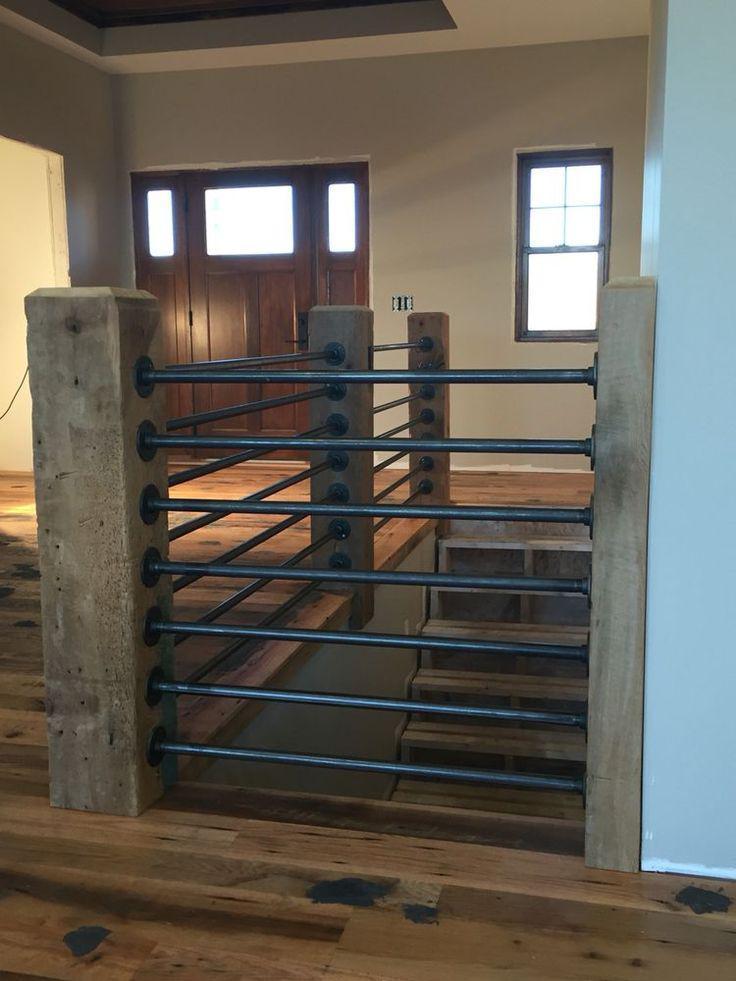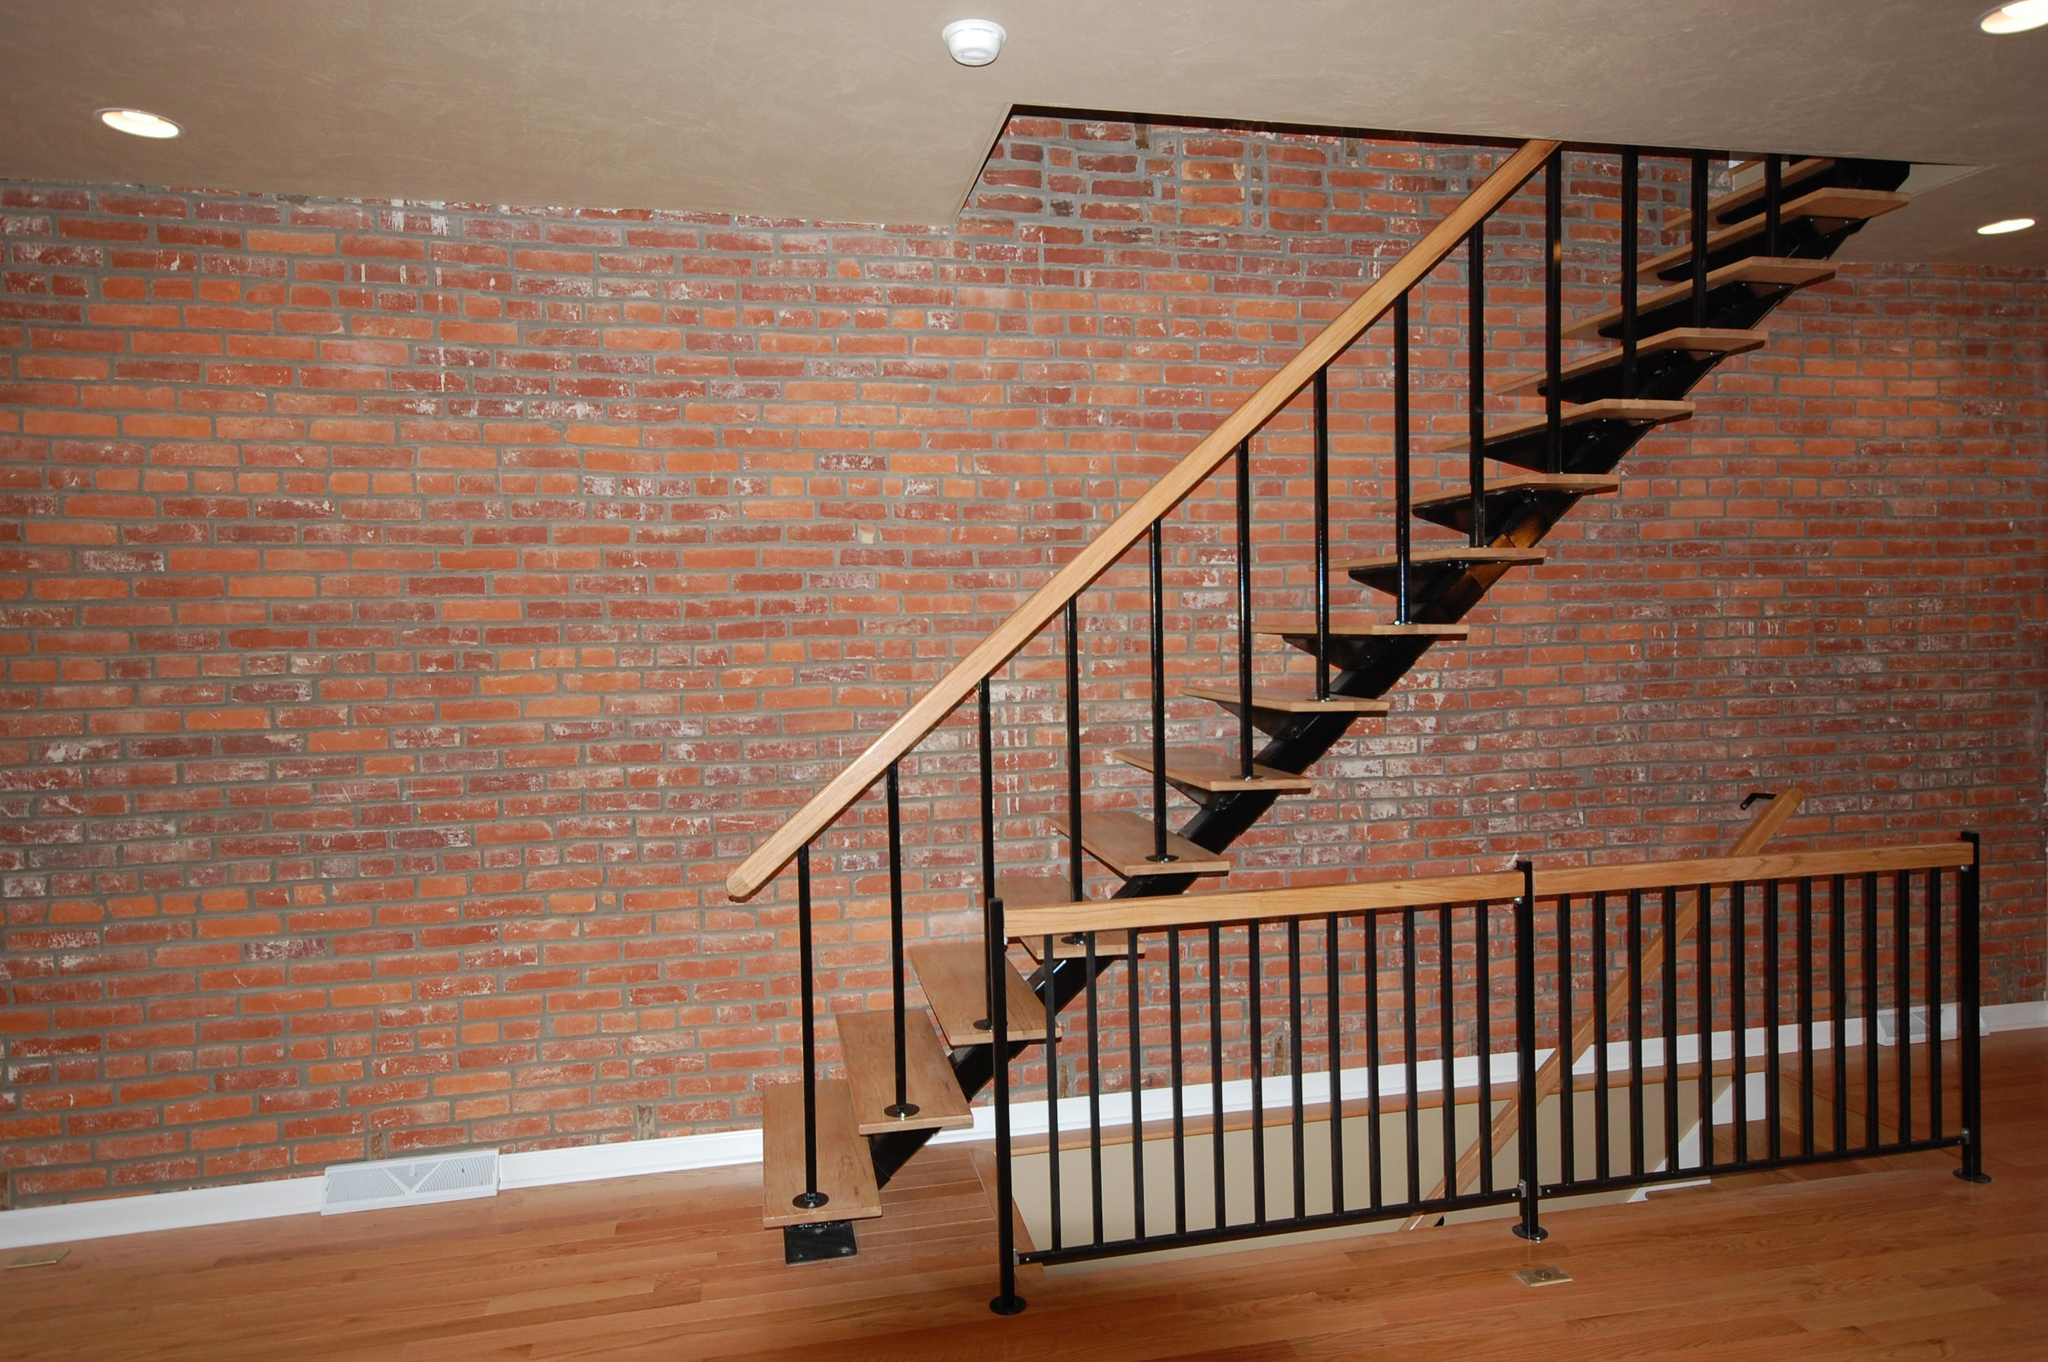The first image is the image on the left, the second image is the image on the right. Considering the images on both sides, is "The right image contains a staircase with a black handrail." valid? Answer yes or no. No. The first image is the image on the left, the second image is the image on the right. Considering the images on both sides, is "One image shows a diagonal 'floating' staircase in front of a brick-like wall and over an open stairwell." valid? Answer yes or no. Yes. 